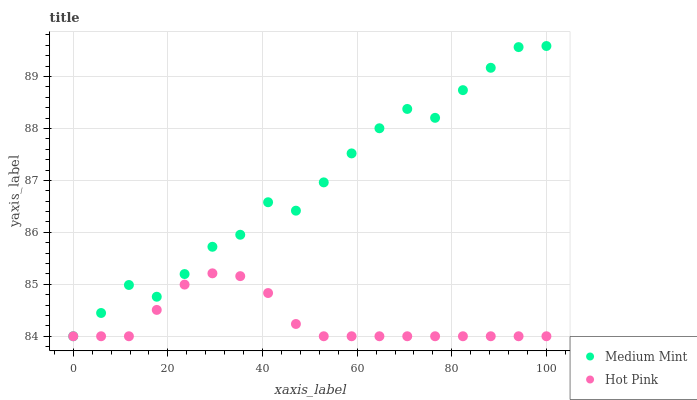Does Hot Pink have the minimum area under the curve?
Answer yes or no. Yes. Does Medium Mint have the maximum area under the curve?
Answer yes or no. Yes. Does Hot Pink have the maximum area under the curve?
Answer yes or no. No. Is Hot Pink the smoothest?
Answer yes or no. Yes. Is Medium Mint the roughest?
Answer yes or no. Yes. Is Hot Pink the roughest?
Answer yes or no. No. Does Medium Mint have the lowest value?
Answer yes or no. Yes. Does Medium Mint have the highest value?
Answer yes or no. Yes. Does Hot Pink have the highest value?
Answer yes or no. No. Does Hot Pink intersect Medium Mint?
Answer yes or no. Yes. Is Hot Pink less than Medium Mint?
Answer yes or no. No. Is Hot Pink greater than Medium Mint?
Answer yes or no. No. 